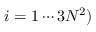Convert formula to latex. <formula><loc_0><loc_0><loc_500><loc_500>i = 1 \cdots 3 N ^ { 2 } )</formula> 